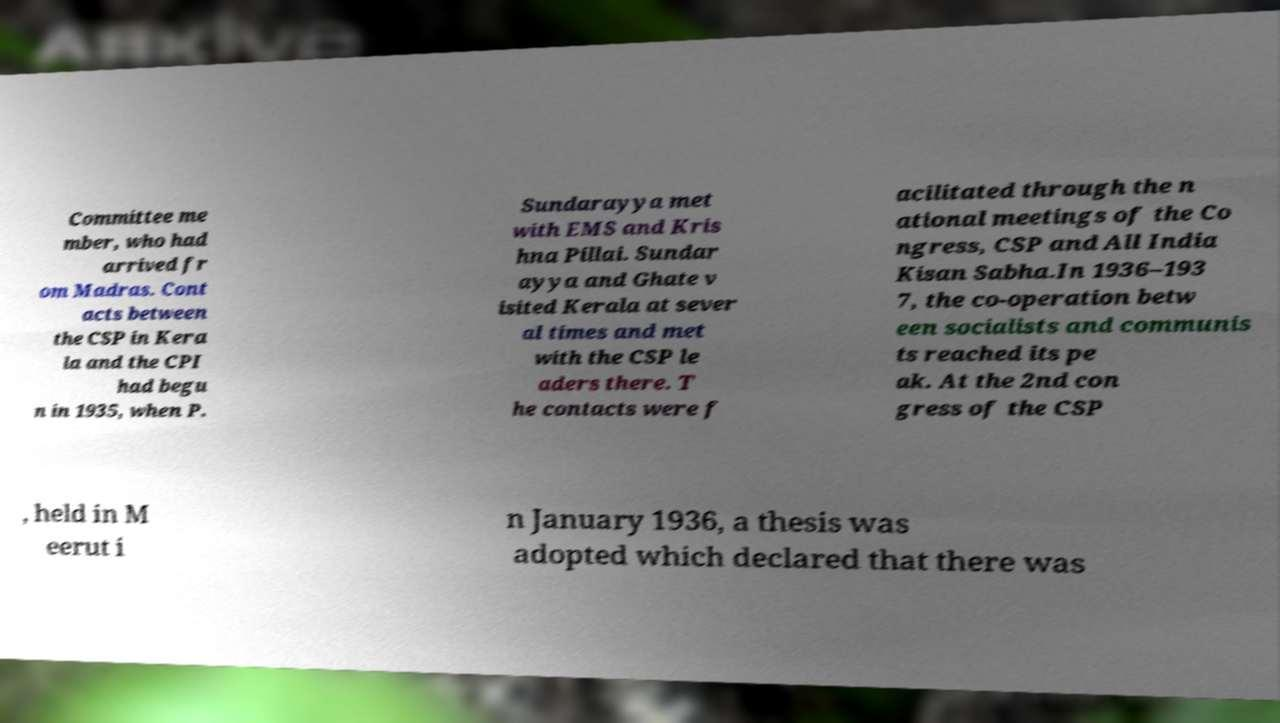Could you assist in decoding the text presented in this image and type it out clearly? Committee me mber, who had arrived fr om Madras. Cont acts between the CSP in Kera la and the CPI had begu n in 1935, when P. Sundarayya met with EMS and Kris hna Pillai. Sundar ayya and Ghate v isited Kerala at sever al times and met with the CSP le aders there. T he contacts were f acilitated through the n ational meetings of the Co ngress, CSP and All India Kisan Sabha.In 1936–193 7, the co-operation betw een socialists and communis ts reached its pe ak. At the 2nd con gress of the CSP , held in M eerut i n January 1936, a thesis was adopted which declared that there was 